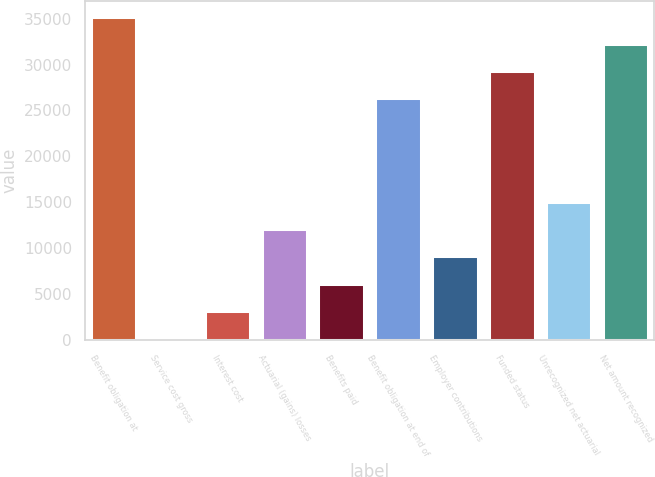Convert chart. <chart><loc_0><loc_0><loc_500><loc_500><bar_chart><fcel>Benefit obligation at<fcel>Service cost gross<fcel>Interest cost<fcel>Actuarial (gains) losses<fcel>Benefits paid<fcel>Benefit obligation at end of<fcel>Employer contributions<fcel>Funded status<fcel>Unrecognized net actuarial<fcel>Net amount recognized<nl><fcel>35213.6<fcel>226<fcel>3181.2<fcel>12046.8<fcel>6136.4<fcel>26348<fcel>9091.6<fcel>29303.2<fcel>15002<fcel>32258.4<nl></chart> 